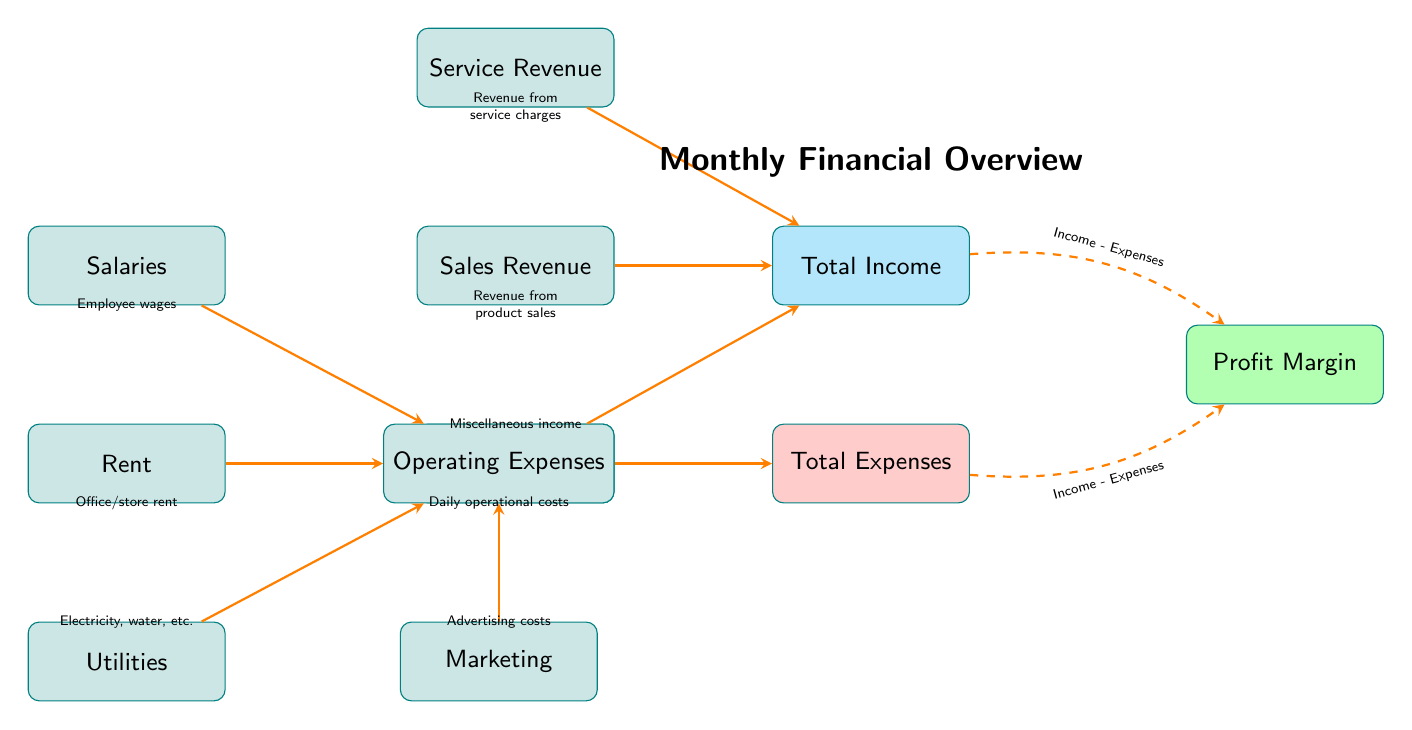What does the "Total Income" node represent? The "Total Income" node aggregates all income sources, which are Sales Revenue, Service Revenue, and Other Income.
Answer: Total Income How many sub-nodes are there under "Total Expenses"? The "Total Expenses" node has four sub-nodes: Salaries, Rent, Utilities, and Marketing, which all contribute to the total expenses.
Answer: Four What is the relationship between "Total Income" and "Profit Margin"? The Profit Margin is calculated by subtracting Total Expenses from Total Income, indicating the financial gain from services or products after covering expenses.
Answer: Income - Expenses Which node is connected directly to the "Operating Expenses" node? "Salaries," "Rent," "Utilities," and "Marketing" are all directly connected to "Operating Expenses," indicating components of the overall expenses.
Answer: Salaries, Rent, Utilities, Marketing What type of revenue is represented by the node "Service Revenue"? "Service Revenue" refers to the income generated from charges for services provided to customers, distinguishing it from product sales.
Answer: Revenue from service charges What does the dashed arrow between "Total Income" and "Profit Margin" signify? The dashed arrow signifies the flow of calculation from Total Income to Profit Margin, specifically expressing that Profit Margin is derived from Total Income minus Total Expenses.
Answer: Income - Expenses How many total nodes are included in the diagram? The diagram contains a main node for "Total Income," "Total Expenses," and "Profit Margin," plus six sub-nodes for different income and expense types, totaling nine nodes.
Answer: Nine What color is the node representing "Total Expenses"? The "Total Expenses" node is filled with a red color, distinguishing it from income-related nodes in the diagram.
Answer: Red What is the meaning of the "Other Income" node? "Other Income" refers to any income that doesn't fall under the categories of Sales Revenue or Service Revenue, encompassing miscellaneous earnings.
Answer: Miscellaneous income 